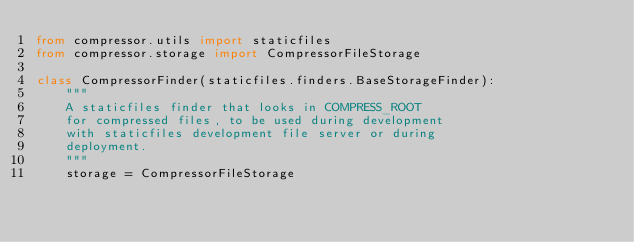Convert code to text. <code><loc_0><loc_0><loc_500><loc_500><_Python_>from compressor.utils import staticfiles
from compressor.storage import CompressorFileStorage

class CompressorFinder(staticfiles.finders.BaseStorageFinder):
    """
    A staticfiles finder that looks in COMPRESS_ROOT
    for compressed files, to be used during development
    with staticfiles development file server or during
    deployment.
    """
    storage = CompressorFileStorage
</code> 